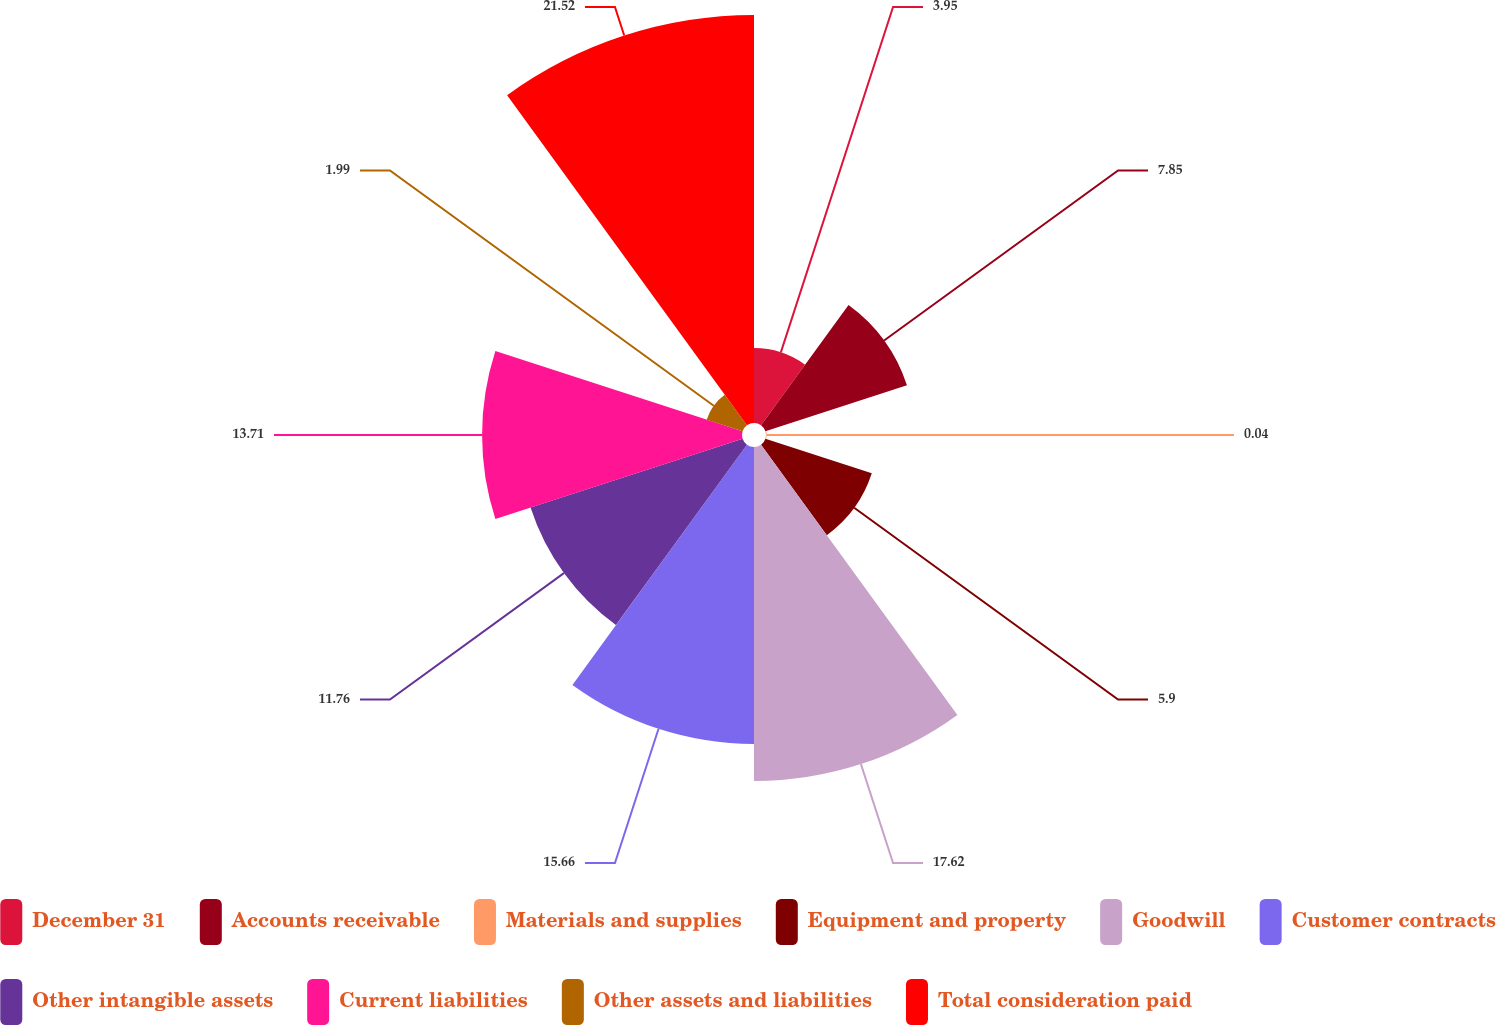<chart> <loc_0><loc_0><loc_500><loc_500><pie_chart><fcel>December 31<fcel>Accounts receivable<fcel>Materials and supplies<fcel>Equipment and property<fcel>Goodwill<fcel>Customer contracts<fcel>Other intangible assets<fcel>Current liabilities<fcel>Other assets and liabilities<fcel>Total consideration paid<nl><fcel>3.95%<fcel>7.85%<fcel>0.04%<fcel>5.9%<fcel>17.62%<fcel>15.66%<fcel>11.76%<fcel>13.71%<fcel>1.99%<fcel>21.52%<nl></chart> 